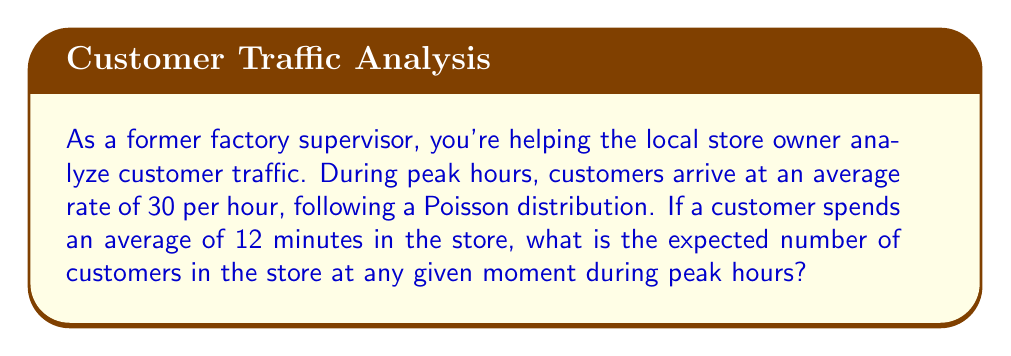What is the answer to this math problem? Let's approach this step-by-step:

1) This scenario describes a queuing system, where we can use Little's Law to find the expected number of customers in the store.

2) Little's Law states that:
   $$ L = \lambda W $$
   Where:
   $L$ = expected number of customers in the system
   $\lambda$ = average arrival rate
   $W$ = average time spent in the system

3) We're given:
   $\lambda = 30$ customers per hour
   $W = 12$ minutes = $\frac{1}{5}$ hour

4) Let's substitute these values into Little's Law:

   $$ L = 30 \cdot \frac{1}{5} = 6 $$

5) Therefore, the expected number of customers in the store at any given moment during peak hours is 6.

This result makes intuitive sense: if 30 customers arrive per hour and each stays for 1/5 of an hour, we'd expect about 6 customers to be in the store at any time.
Answer: The expected number of customers in the store during peak hours is 6. 